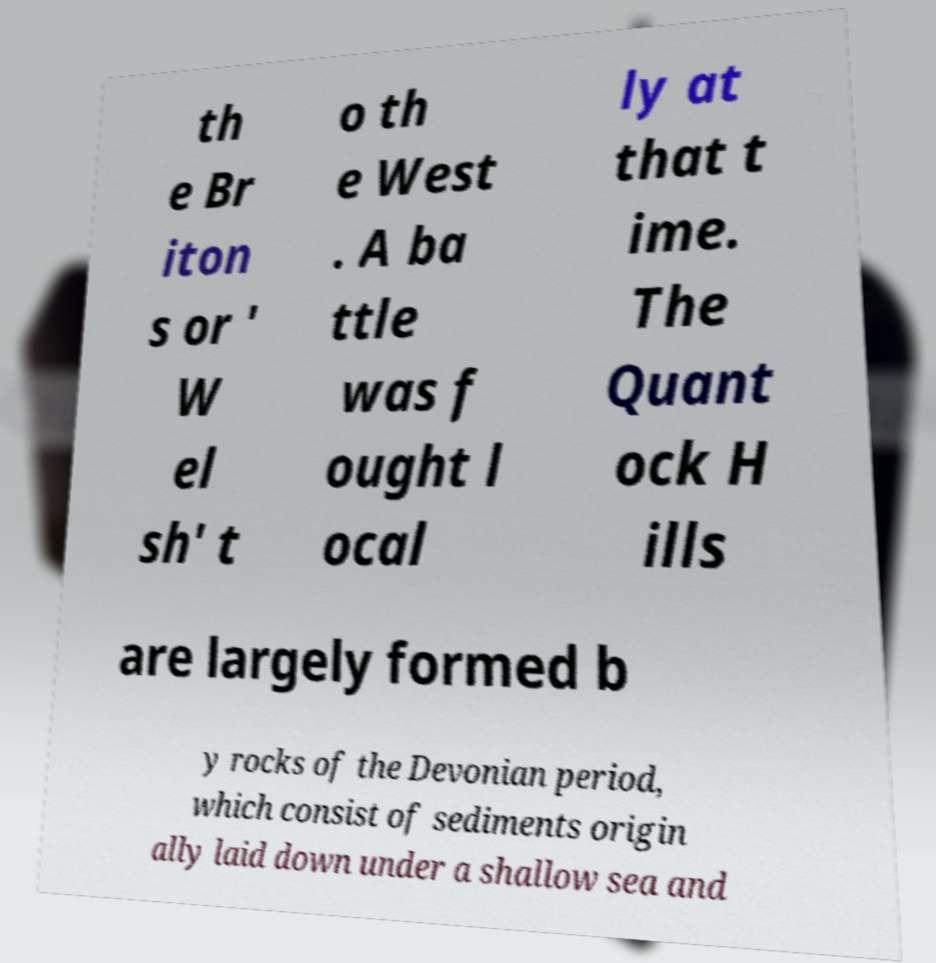I need the written content from this picture converted into text. Can you do that? th e Br iton s or ' W el sh' t o th e West . A ba ttle was f ought l ocal ly at that t ime. The Quant ock H ills are largely formed b y rocks of the Devonian period, which consist of sediments origin ally laid down under a shallow sea and 